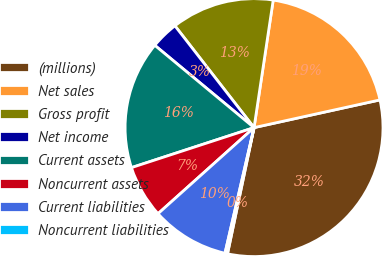<chart> <loc_0><loc_0><loc_500><loc_500><pie_chart><fcel>(millions)<fcel>Net sales<fcel>Gross profit<fcel>Net income<fcel>Current assets<fcel>Noncurrent assets<fcel>Current liabilities<fcel>Noncurrent liabilities<nl><fcel>31.75%<fcel>19.18%<fcel>12.89%<fcel>3.47%<fcel>16.04%<fcel>6.61%<fcel>9.75%<fcel>0.32%<nl></chart> 